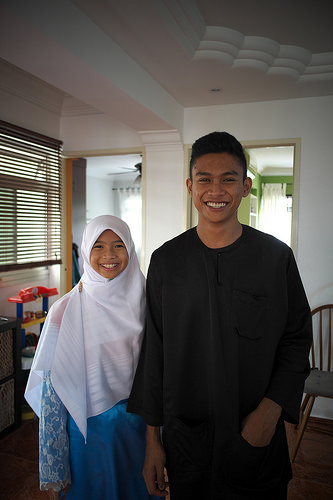<image>
Is there a boy under the girl? No. The boy is not positioned under the girl. The vertical relationship between these objects is different. Is there a boy to the left of the girl? Yes. From this viewpoint, the boy is positioned to the left side relative to the girl. 